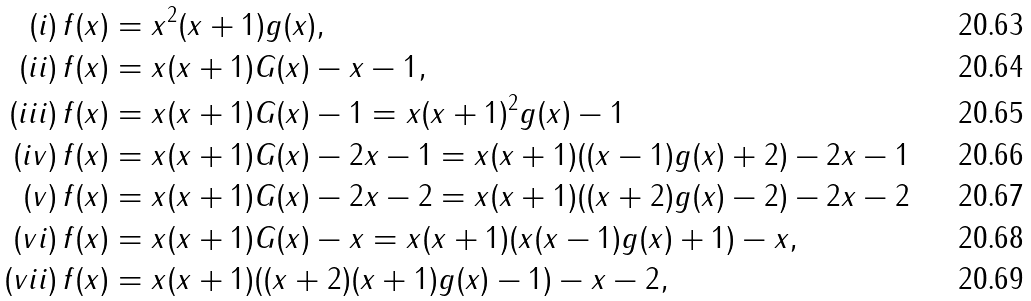<formula> <loc_0><loc_0><loc_500><loc_500>( i ) \, f ( x ) & = x ^ { 2 } ( x + 1 ) g ( x ) , \\ ( i i ) \, f ( x ) & = x ( x + 1 ) G ( x ) - x - 1 , \\ ( i i i ) \, f ( x ) & = x ( x + 1 ) G ( x ) - 1 = x ( x + 1 ) ^ { 2 } g ( x ) - 1 \\ ( i v ) \, f ( x ) & = x ( x + 1 ) G ( x ) - 2 x - 1 = x ( x + 1 ) ( ( x - 1 ) g ( x ) + 2 ) - 2 x - 1 \\ ( v ) \, f ( x ) & = x ( x + 1 ) G ( x ) - 2 x - 2 = x ( x + 1 ) ( ( x + 2 ) g ( x ) - 2 ) - 2 x - 2 \\ ( v i ) \, f ( x ) & = x ( x + 1 ) G ( x ) - x = x ( x + 1 ) ( x ( x - 1 ) g ( x ) + 1 ) - x , \\ ( v i i ) \, f ( x ) & = x ( x + 1 ) ( ( x + 2 ) ( x + 1 ) g ( x ) - 1 ) - x - 2 ,</formula> 